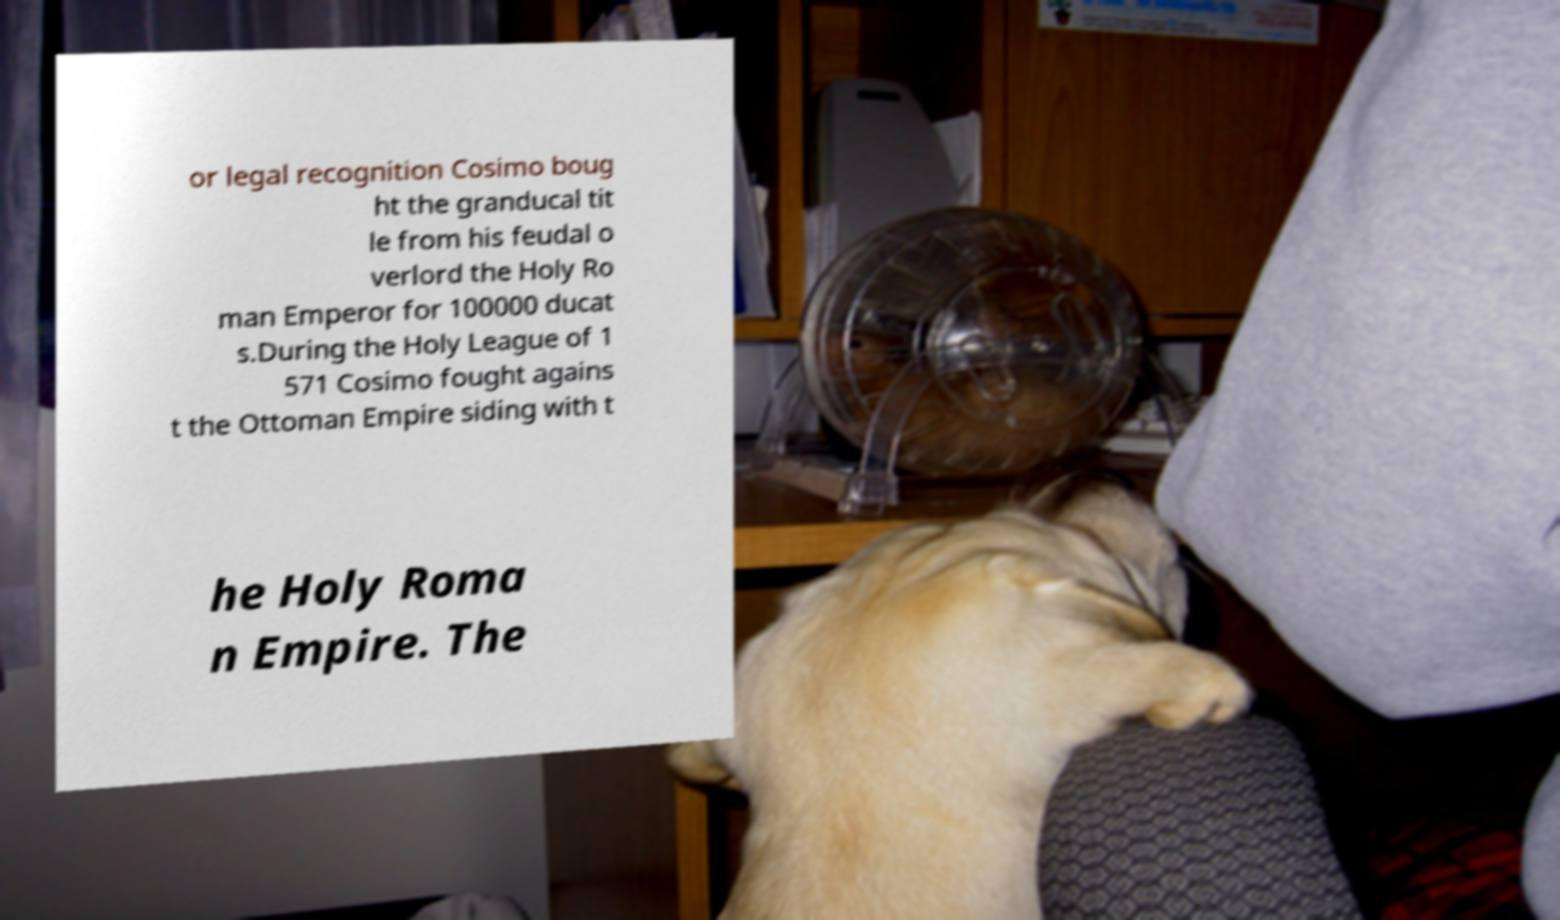What messages or text are displayed in this image? I need them in a readable, typed format. or legal recognition Cosimo boug ht the granducal tit le from his feudal o verlord the Holy Ro man Emperor for 100000 ducat s.During the Holy League of 1 571 Cosimo fought agains t the Ottoman Empire siding with t he Holy Roma n Empire. The 